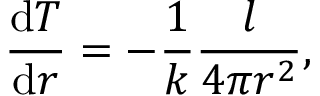Convert formula to latex. <formula><loc_0><loc_0><loc_500><loc_500>{ \frac { { d } T } { { d } r } } = - { \frac { 1 } { k } } { \frac { l } { 4 \pi r ^ { 2 } } } ,</formula> 